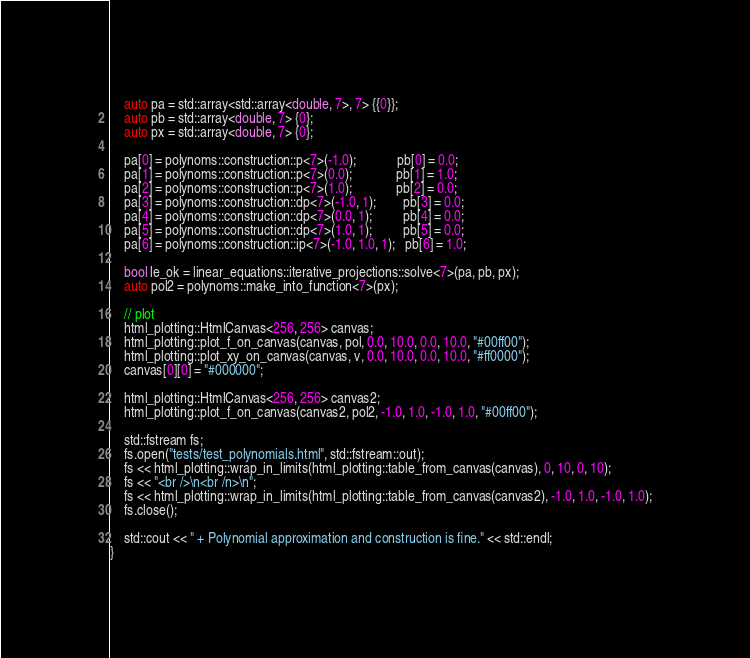<code> <loc_0><loc_0><loc_500><loc_500><_C++_>    auto pa = std::array<std::array<double, 7>, 7> {{0}};
    auto pb = std::array<double, 7> {0};
    auto px = std::array<double, 7> {0};

    pa[0] = polynoms::construction::p<7>(-1.0);            pb[0] = 0.0;
    pa[1] = polynoms::construction::p<7>(0.0);             pb[1] = 1.0;
    pa[2] = polynoms::construction::p<7>(1.0);             pb[2] = 0.0;
    pa[3] = polynoms::construction::dp<7>(-1.0, 1);        pb[3] = 0.0;
    pa[4] = polynoms::construction::dp<7>(0.0, 1);         pb[4] = 0.0;
    pa[5] = polynoms::construction::dp<7>(1.0, 1);         pb[5] = 0.0;
    pa[6] = polynoms::construction::ip<7>(-1.0, 1.0, 1);   pb[6] = 1.0;

    bool le_ok = linear_equations::iterative_projections::solve<7>(pa, pb, px);
    auto pol2 = polynoms::make_into_function<7>(px);

    // plot
    html_plotting::HtmlCanvas<256, 256> canvas;
    html_plotting::plot_f_on_canvas(canvas, pol, 0.0, 10.0, 0.0, 10.0, "#00ff00");
    html_plotting::plot_xy_on_canvas(canvas, v, 0.0, 10.0, 0.0, 10.0, "#ff0000");
    canvas[0][0] = "#000000";

    html_plotting::HtmlCanvas<256, 256> canvas2;
    html_plotting::plot_f_on_canvas(canvas2, pol2, -1.0, 1.0, -1.0, 1.0, "#00ff00");

    std::fstream fs;
    fs.open("tests/test_polynomials.html", std::fstream::out);
    fs << html_plotting::wrap_in_limits(html_plotting::table_from_canvas(canvas), 0, 10, 0, 10);
    fs << "<br />\n<br /n>\n";
    fs << html_plotting::wrap_in_limits(html_plotting::table_from_canvas(canvas2), -1.0, 1.0, -1.0, 1.0);
    fs.close();

    std::cout << " + Polynomial approximation and construction is fine." << std::endl;
}
</code> 